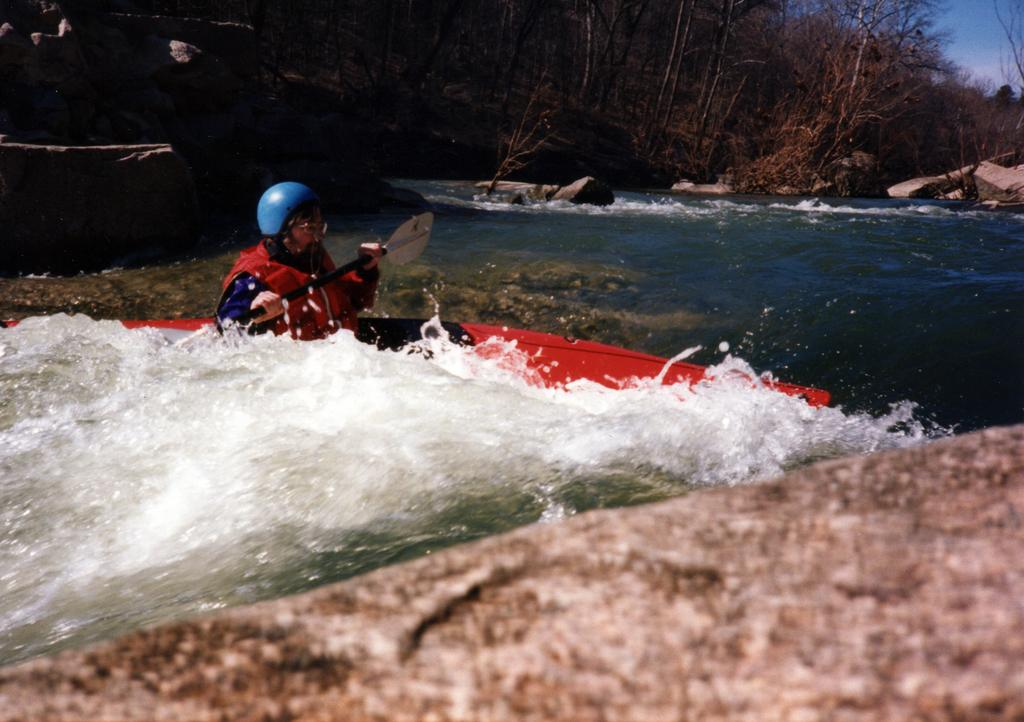What is the person in the image doing? The person is rowing a boat. Where is the boat located? The boat is on the water. What can be seen in the background of the image? There are rocks, trees, and the sky visible in the background of the image. What type of scarf is the person wearing while rowing the boat? There is no scarf visible in the image; the person is not wearing one. Can you hear the sound of the boat hitting the rocks in the image? The image is silent, so it is not possible to hear any sounds. 